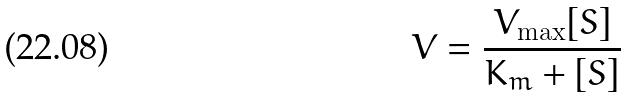Convert formula to latex. <formula><loc_0><loc_0><loc_500><loc_500>V = \frac { V _ { \max } [ S ] } { K _ { m } + [ S ] }</formula> 